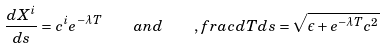<formula> <loc_0><loc_0><loc_500><loc_500>\frac { d X ^ { i } } { d s } = c ^ { i } e ^ { - \lambda T } \quad a n d \quad , f r a c { d T } { d s } = \sqrt { \epsilon + e ^ { - \lambda T } { c } ^ { 2 } }</formula> 